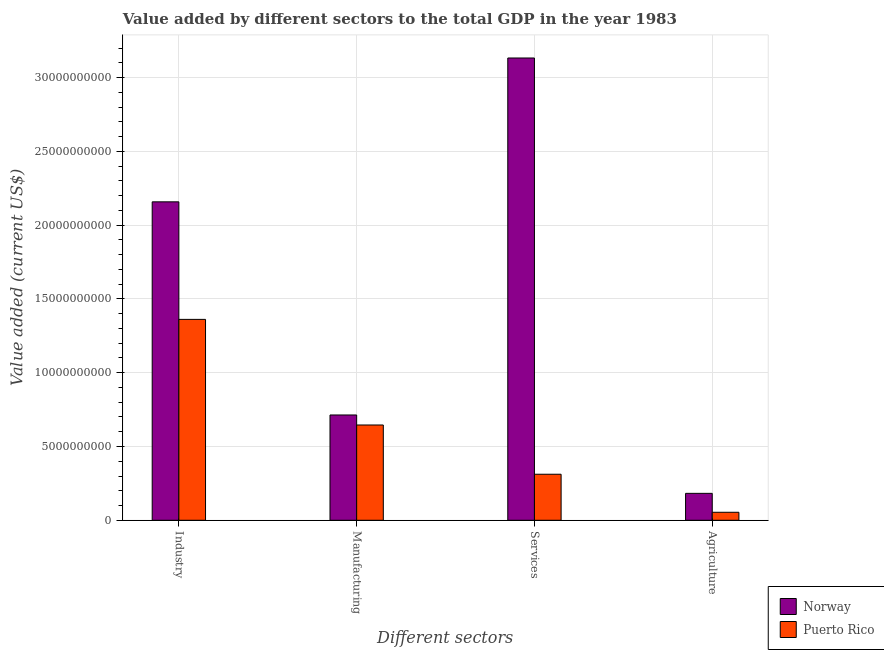Are the number of bars per tick equal to the number of legend labels?
Provide a short and direct response. Yes. Are the number of bars on each tick of the X-axis equal?
Your response must be concise. Yes. How many bars are there on the 3rd tick from the left?
Provide a succinct answer. 2. How many bars are there on the 2nd tick from the right?
Your response must be concise. 2. What is the label of the 3rd group of bars from the left?
Keep it short and to the point. Services. What is the value added by manufacturing sector in Norway?
Offer a terse response. 7.14e+09. Across all countries, what is the maximum value added by services sector?
Your answer should be compact. 3.13e+1. Across all countries, what is the minimum value added by industrial sector?
Offer a very short reply. 1.36e+1. In which country was the value added by industrial sector minimum?
Make the answer very short. Puerto Rico. What is the total value added by industrial sector in the graph?
Ensure brevity in your answer.  3.52e+1. What is the difference between the value added by services sector in Norway and that in Puerto Rico?
Give a very brief answer. 2.82e+1. What is the difference between the value added by agricultural sector in Norway and the value added by manufacturing sector in Puerto Rico?
Your answer should be very brief. -4.63e+09. What is the average value added by manufacturing sector per country?
Make the answer very short. 6.80e+09. What is the difference between the value added by services sector and value added by industrial sector in Norway?
Provide a short and direct response. 9.75e+09. What is the ratio of the value added by industrial sector in Puerto Rico to that in Norway?
Your answer should be compact. 0.63. What is the difference between the highest and the second highest value added by services sector?
Offer a terse response. 2.82e+1. What is the difference between the highest and the lowest value added by manufacturing sector?
Provide a succinct answer. 6.79e+08. Is the sum of the value added by industrial sector in Norway and Puerto Rico greater than the maximum value added by manufacturing sector across all countries?
Provide a succinct answer. Yes. Is it the case that in every country, the sum of the value added by manufacturing sector and value added by services sector is greater than the sum of value added by agricultural sector and value added by industrial sector?
Your answer should be compact. No. What does the 2nd bar from the left in Services represents?
Provide a succinct answer. Puerto Rico. What does the 2nd bar from the right in Agriculture represents?
Provide a short and direct response. Norway. How many bars are there?
Keep it short and to the point. 8. Are all the bars in the graph horizontal?
Your response must be concise. No. How many countries are there in the graph?
Offer a terse response. 2. What is the difference between two consecutive major ticks on the Y-axis?
Offer a very short reply. 5.00e+09. Are the values on the major ticks of Y-axis written in scientific E-notation?
Offer a terse response. No. Where does the legend appear in the graph?
Offer a terse response. Bottom right. What is the title of the graph?
Give a very brief answer. Value added by different sectors to the total GDP in the year 1983. What is the label or title of the X-axis?
Offer a terse response. Different sectors. What is the label or title of the Y-axis?
Keep it short and to the point. Value added (current US$). What is the Value added (current US$) of Norway in Industry?
Your answer should be compact. 2.16e+1. What is the Value added (current US$) in Puerto Rico in Industry?
Provide a succinct answer. 1.36e+1. What is the Value added (current US$) in Norway in Manufacturing?
Your answer should be compact. 7.14e+09. What is the Value added (current US$) in Puerto Rico in Manufacturing?
Provide a short and direct response. 6.46e+09. What is the Value added (current US$) in Norway in Services?
Provide a succinct answer. 3.13e+1. What is the Value added (current US$) in Puerto Rico in Services?
Offer a terse response. 3.12e+09. What is the Value added (current US$) in Norway in Agriculture?
Your response must be concise. 1.82e+09. What is the Value added (current US$) of Puerto Rico in Agriculture?
Give a very brief answer. 5.41e+08. Across all Different sectors, what is the maximum Value added (current US$) of Norway?
Provide a succinct answer. 3.13e+1. Across all Different sectors, what is the maximum Value added (current US$) of Puerto Rico?
Ensure brevity in your answer.  1.36e+1. Across all Different sectors, what is the minimum Value added (current US$) in Norway?
Make the answer very short. 1.82e+09. Across all Different sectors, what is the minimum Value added (current US$) in Puerto Rico?
Offer a terse response. 5.41e+08. What is the total Value added (current US$) in Norway in the graph?
Make the answer very short. 6.19e+1. What is the total Value added (current US$) in Puerto Rico in the graph?
Ensure brevity in your answer.  2.37e+1. What is the difference between the Value added (current US$) of Norway in Industry and that in Manufacturing?
Offer a terse response. 1.44e+1. What is the difference between the Value added (current US$) in Puerto Rico in Industry and that in Manufacturing?
Your response must be concise. 7.16e+09. What is the difference between the Value added (current US$) in Norway in Industry and that in Services?
Your answer should be very brief. -9.75e+09. What is the difference between the Value added (current US$) of Puerto Rico in Industry and that in Services?
Ensure brevity in your answer.  1.05e+1. What is the difference between the Value added (current US$) in Norway in Industry and that in Agriculture?
Provide a short and direct response. 1.98e+1. What is the difference between the Value added (current US$) of Puerto Rico in Industry and that in Agriculture?
Provide a short and direct response. 1.31e+1. What is the difference between the Value added (current US$) of Norway in Manufacturing and that in Services?
Ensure brevity in your answer.  -2.42e+1. What is the difference between the Value added (current US$) of Puerto Rico in Manufacturing and that in Services?
Give a very brief answer. 3.34e+09. What is the difference between the Value added (current US$) in Norway in Manufacturing and that in Agriculture?
Ensure brevity in your answer.  5.31e+09. What is the difference between the Value added (current US$) in Puerto Rico in Manufacturing and that in Agriculture?
Offer a terse response. 5.92e+09. What is the difference between the Value added (current US$) of Norway in Services and that in Agriculture?
Offer a terse response. 2.95e+1. What is the difference between the Value added (current US$) in Puerto Rico in Services and that in Agriculture?
Keep it short and to the point. 2.58e+09. What is the difference between the Value added (current US$) of Norway in Industry and the Value added (current US$) of Puerto Rico in Manufacturing?
Your answer should be compact. 1.51e+1. What is the difference between the Value added (current US$) in Norway in Industry and the Value added (current US$) in Puerto Rico in Services?
Make the answer very short. 1.85e+1. What is the difference between the Value added (current US$) of Norway in Industry and the Value added (current US$) of Puerto Rico in Agriculture?
Provide a succinct answer. 2.10e+1. What is the difference between the Value added (current US$) of Norway in Manufacturing and the Value added (current US$) of Puerto Rico in Services?
Offer a terse response. 4.02e+09. What is the difference between the Value added (current US$) in Norway in Manufacturing and the Value added (current US$) in Puerto Rico in Agriculture?
Provide a short and direct response. 6.60e+09. What is the difference between the Value added (current US$) of Norway in Services and the Value added (current US$) of Puerto Rico in Agriculture?
Offer a terse response. 3.08e+1. What is the average Value added (current US$) of Norway per Different sectors?
Your answer should be very brief. 1.55e+1. What is the average Value added (current US$) of Puerto Rico per Different sectors?
Keep it short and to the point. 5.93e+09. What is the difference between the Value added (current US$) in Norway and Value added (current US$) in Puerto Rico in Industry?
Keep it short and to the point. 7.97e+09. What is the difference between the Value added (current US$) of Norway and Value added (current US$) of Puerto Rico in Manufacturing?
Offer a terse response. 6.79e+08. What is the difference between the Value added (current US$) in Norway and Value added (current US$) in Puerto Rico in Services?
Ensure brevity in your answer.  2.82e+1. What is the difference between the Value added (current US$) of Norway and Value added (current US$) of Puerto Rico in Agriculture?
Your answer should be very brief. 1.28e+09. What is the ratio of the Value added (current US$) in Norway in Industry to that in Manufacturing?
Your response must be concise. 3.02. What is the ratio of the Value added (current US$) of Puerto Rico in Industry to that in Manufacturing?
Your response must be concise. 2.11. What is the ratio of the Value added (current US$) in Norway in Industry to that in Services?
Your answer should be very brief. 0.69. What is the ratio of the Value added (current US$) of Puerto Rico in Industry to that in Services?
Your answer should be compact. 4.36. What is the ratio of the Value added (current US$) in Norway in Industry to that in Agriculture?
Your response must be concise. 11.83. What is the ratio of the Value added (current US$) in Puerto Rico in Industry to that in Agriculture?
Your answer should be compact. 25.15. What is the ratio of the Value added (current US$) in Norway in Manufacturing to that in Services?
Provide a succinct answer. 0.23. What is the ratio of the Value added (current US$) in Puerto Rico in Manufacturing to that in Services?
Your answer should be compact. 2.07. What is the ratio of the Value added (current US$) in Norway in Manufacturing to that in Agriculture?
Ensure brevity in your answer.  3.91. What is the ratio of the Value added (current US$) of Puerto Rico in Manufacturing to that in Agriculture?
Your answer should be very brief. 11.93. What is the ratio of the Value added (current US$) in Norway in Services to that in Agriculture?
Provide a short and direct response. 17.18. What is the ratio of the Value added (current US$) in Puerto Rico in Services to that in Agriculture?
Your answer should be very brief. 5.76. What is the difference between the highest and the second highest Value added (current US$) in Norway?
Your answer should be very brief. 9.75e+09. What is the difference between the highest and the second highest Value added (current US$) of Puerto Rico?
Provide a short and direct response. 7.16e+09. What is the difference between the highest and the lowest Value added (current US$) in Norway?
Your response must be concise. 2.95e+1. What is the difference between the highest and the lowest Value added (current US$) in Puerto Rico?
Keep it short and to the point. 1.31e+1. 